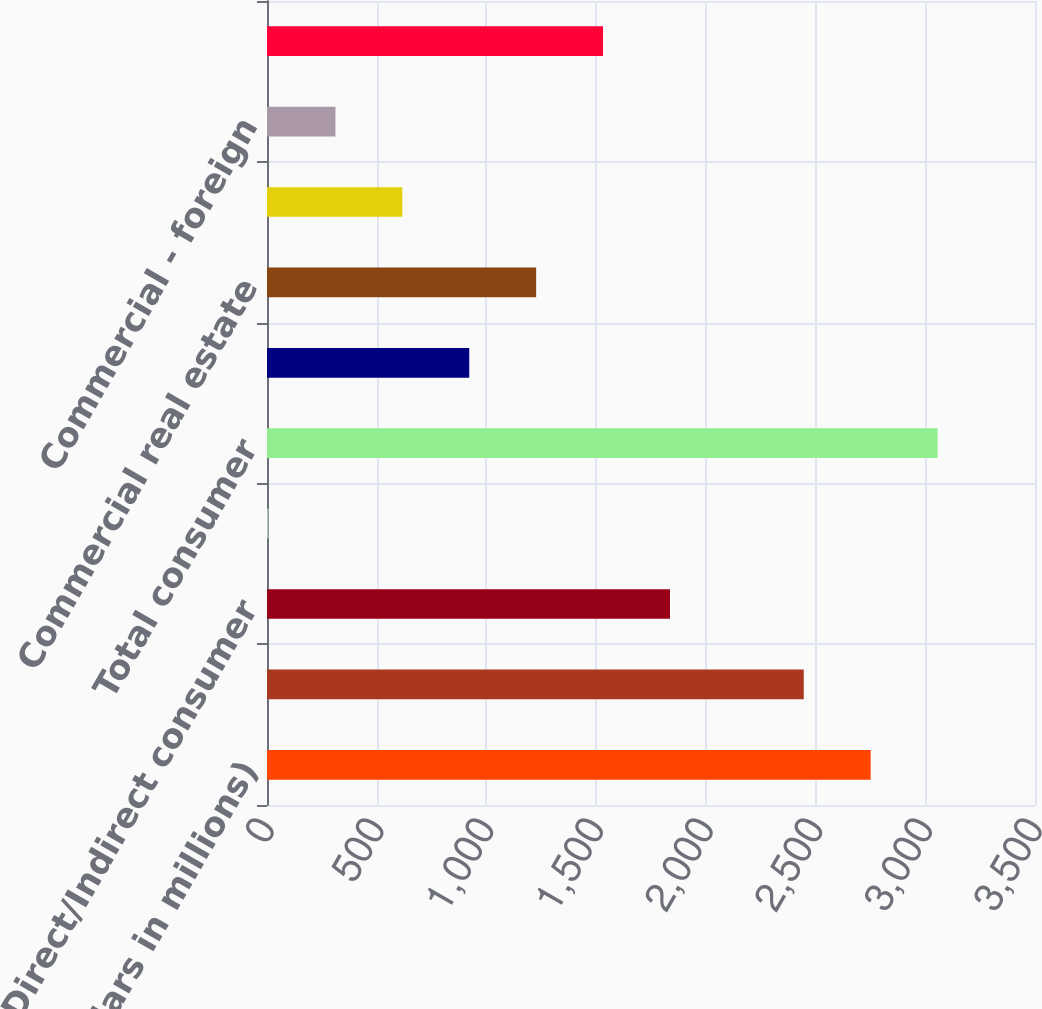Convert chart. <chart><loc_0><loc_0><loc_500><loc_500><bar_chart><fcel>(Dollars in millions)<fcel>Credit card - domestic<fcel>Direct/Indirect consumer<fcel>Other consumer<fcel>Total consumer<fcel>Commercial - domestic (3)<fcel>Commercial real estate<fcel>Commercial lease financing<fcel>Commercial - foreign<fcel>Small business commercial -<nl><fcel>2751.1<fcel>2446.2<fcel>1836.4<fcel>7<fcel>3056<fcel>921.7<fcel>1226.6<fcel>616.8<fcel>311.9<fcel>1531.5<nl></chart> 